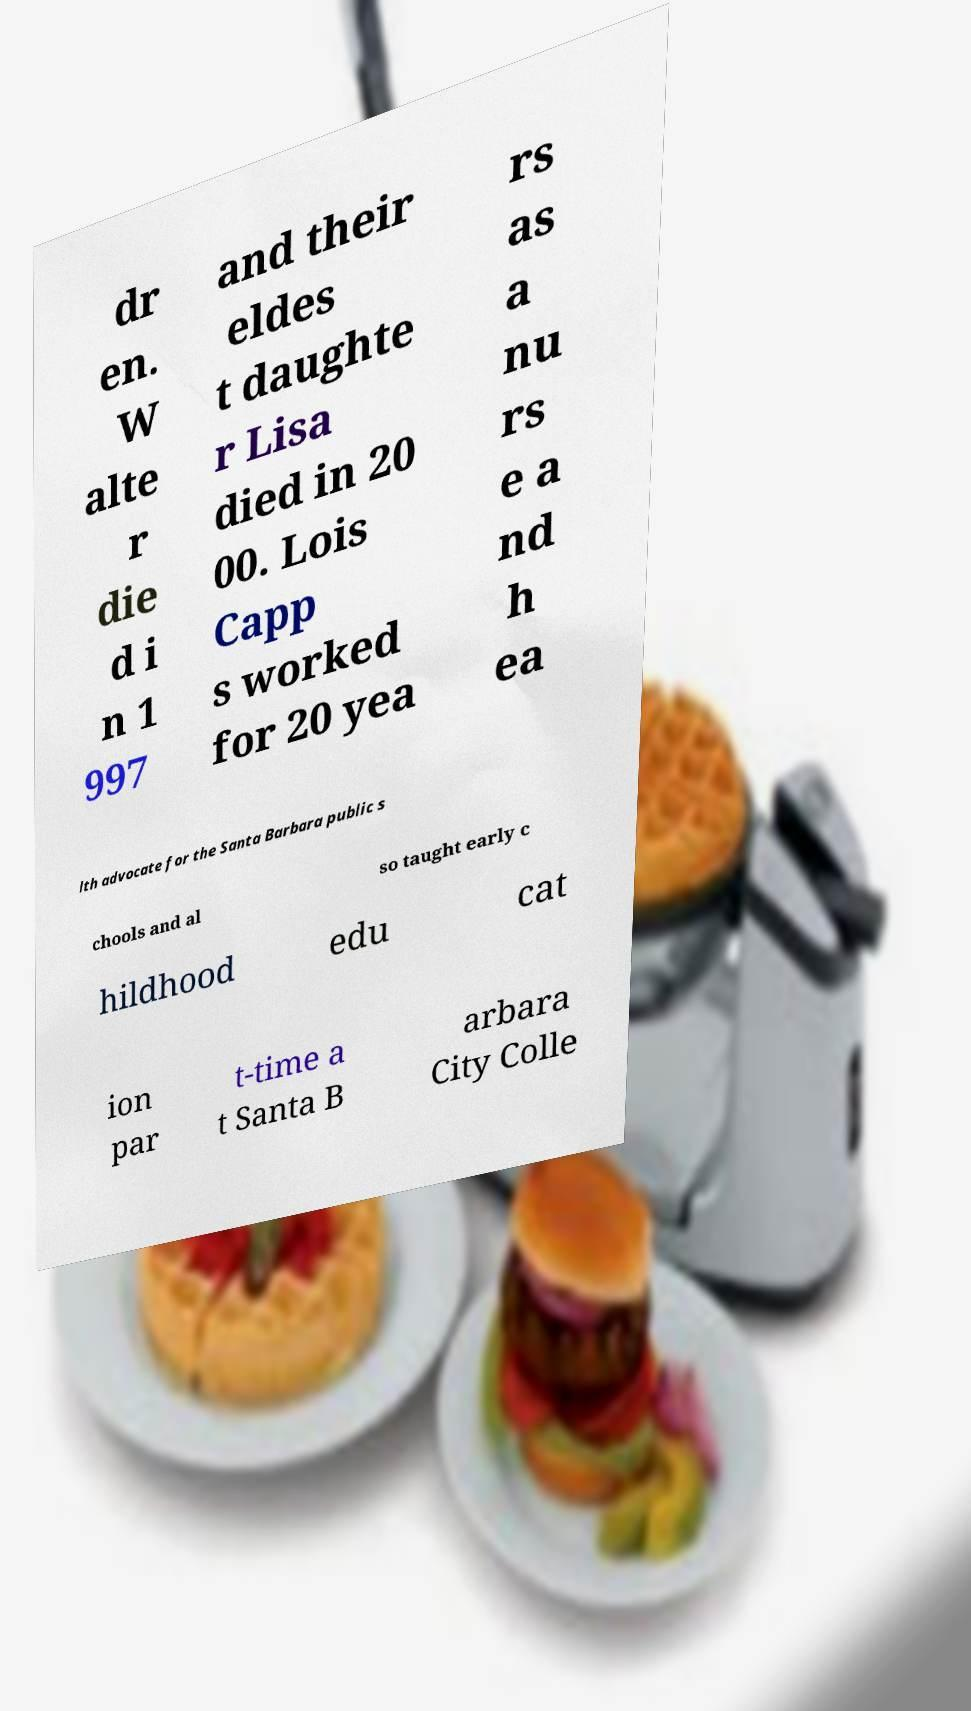Please identify and transcribe the text found in this image. dr en. W alte r die d i n 1 997 and their eldes t daughte r Lisa died in 20 00. Lois Capp s worked for 20 yea rs as a nu rs e a nd h ea lth advocate for the Santa Barbara public s chools and al so taught early c hildhood edu cat ion par t-time a t Santa B arbara City Colle 